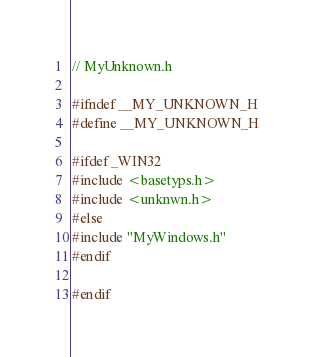Convert code to text. <code><loc_0><loc_0><loc_500><loc_500><_C_>// MyUnknown.h

#ifndef __MY_UNKNOWN_H
#define __MY_UNKNOWN_H

#ifdef _WIN32
#include <basetyps.h>
#include <unknwn.h>
#else
#include "MyWindows.h"
#endif
  
#endif
</code> 